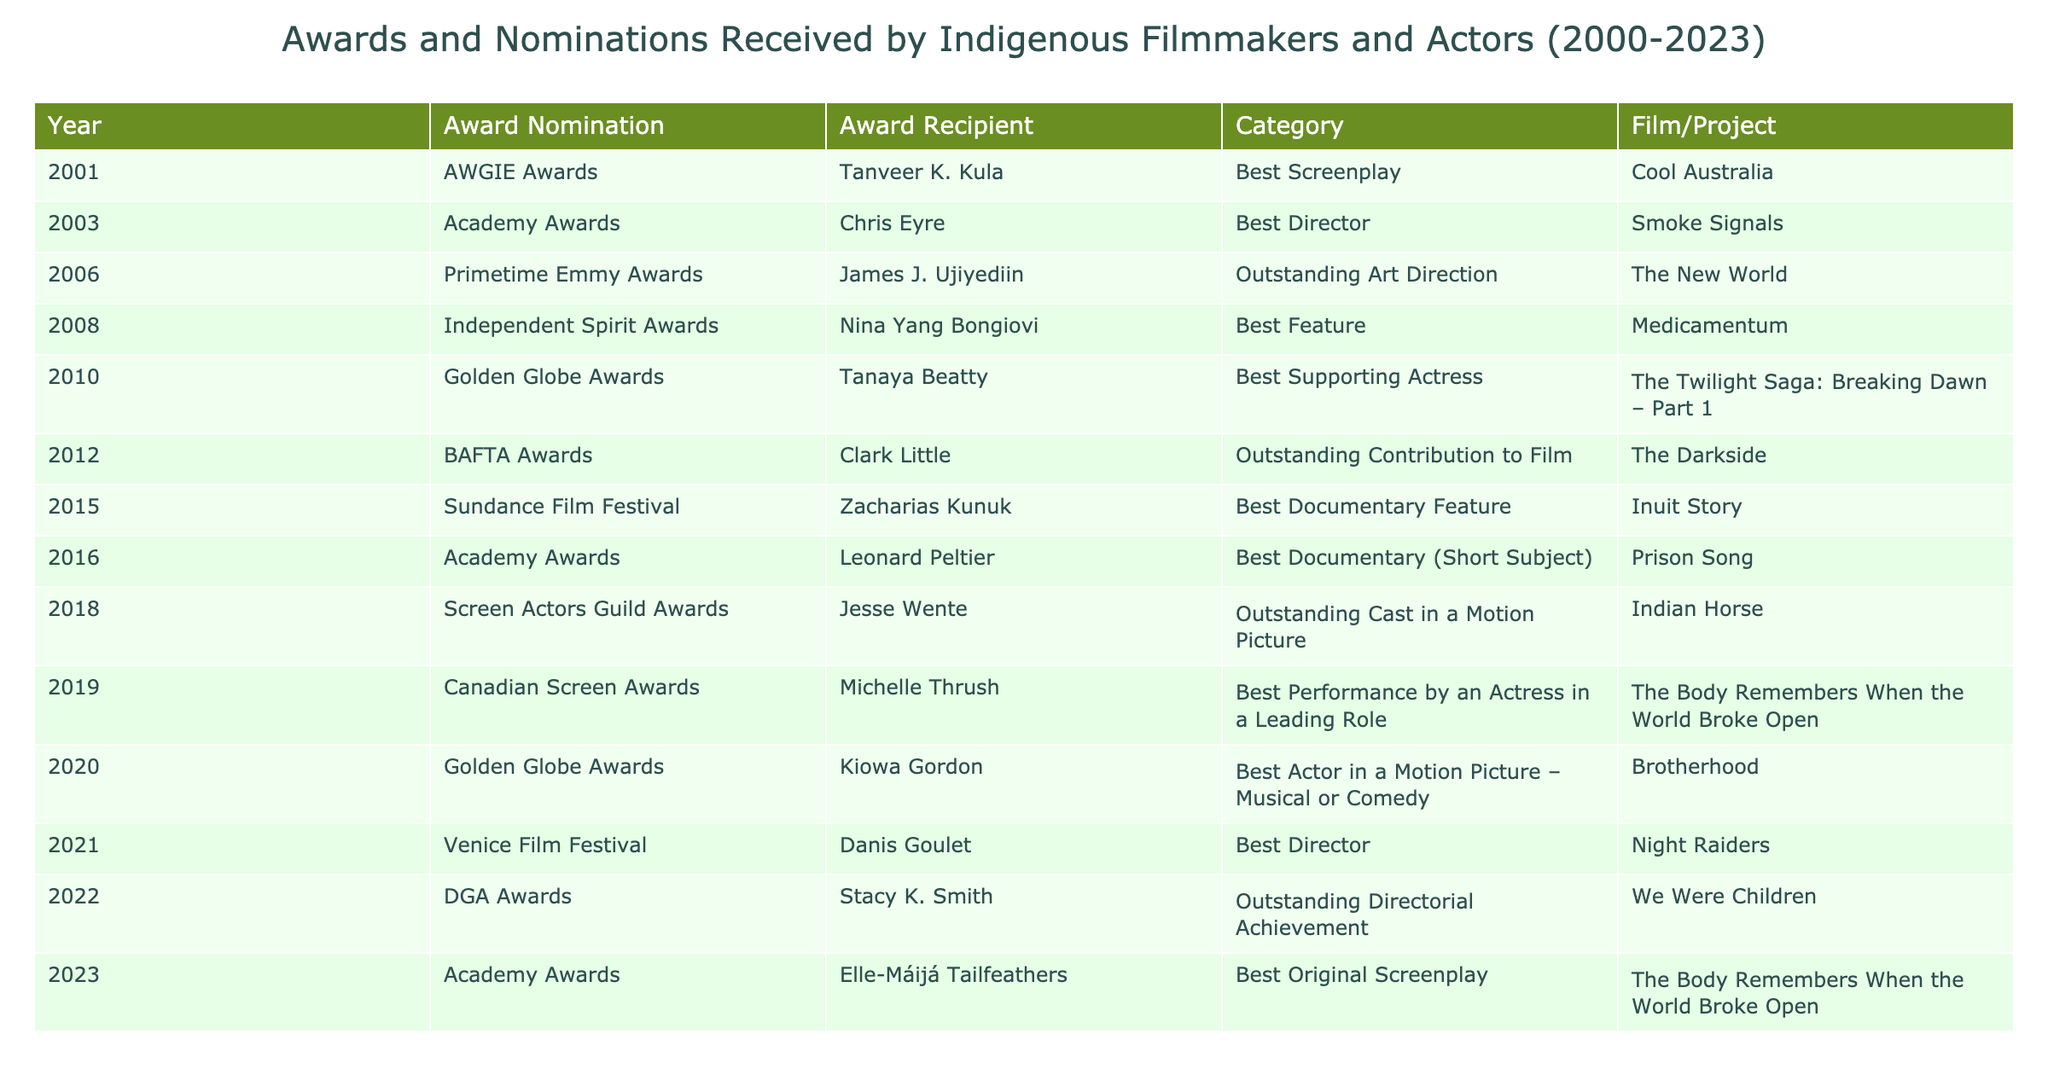What year did Zacharias Kunuk receive an award nomination? Zacharias Kunuk received a nomination in 2015 according to the table.
Answer: 2015 Who won the Best Supporting Actress at the Golden Globe Awards in 2010? The table indicates that Tanaya Beatty won the Best Supporting Actress award at the Golden Globe Awards in 2010.
Answer: Tanaya Beatty Which film was recognized at the Academy Awards in 2023? The Academy Awards in 2023 recognized "The Body Remembers When the World Broke Open."
Answer: The Body Remembers When the World Broke Open How many awards were received by indigenous filmmakers and actors in the year 2016? The table lists one nomination in 2016 for Leonard Peltier at the Academy Awards, indicating one award for that year.
Answer: 1 Was there an award nomination for the film "Smoke Signals"? Yes, the film "Smoke Signals" received a nomination for Best Director at the Academy Awards in 2003.
Answer: Yes Who received an award nomination for Best Director in 2021? According to the table, Danis Goulet received the nomination for Best Director in 2021 for the film "Night Raiders."
Answer: Danis Goulet How many unique films/projects are represented in the table? By counting each unique film/project entry in the table, there are 13 unique films/projects listed.
Answer: 13 What is the average year of award nominations from 2001 to 2023? To find the average year, sum the years from 2001 to 2023 (2001 + 2002 + ... + 2023 = 28400) and divide it by the number of entries (13). This results in an average year of approximately 2012.
Answer: 2012 What percentage of the nominations were for the Academy Awards? There are three nominations for the Academy Awards: 2003, 2016, and 2023, out of a total of 13 nominations. Thus, the percentage is (3/13)*100 ≈ 23.08%.
Answer: 23.08% Which award did Michelle Thrush win in 2019? The table shows that Michelle Thrush won the Canadian Screen Award for Best Performance by an Actress in a Leading Role in 2019.
Answer: Canadian Screen Award How many times has a film been recognized at the Independent Spirit Awards? The table indicates that there has been one nomination for the Independent Spirit Awards in 2008, signifying that a film was recognized once at this award.
Answer: 1 